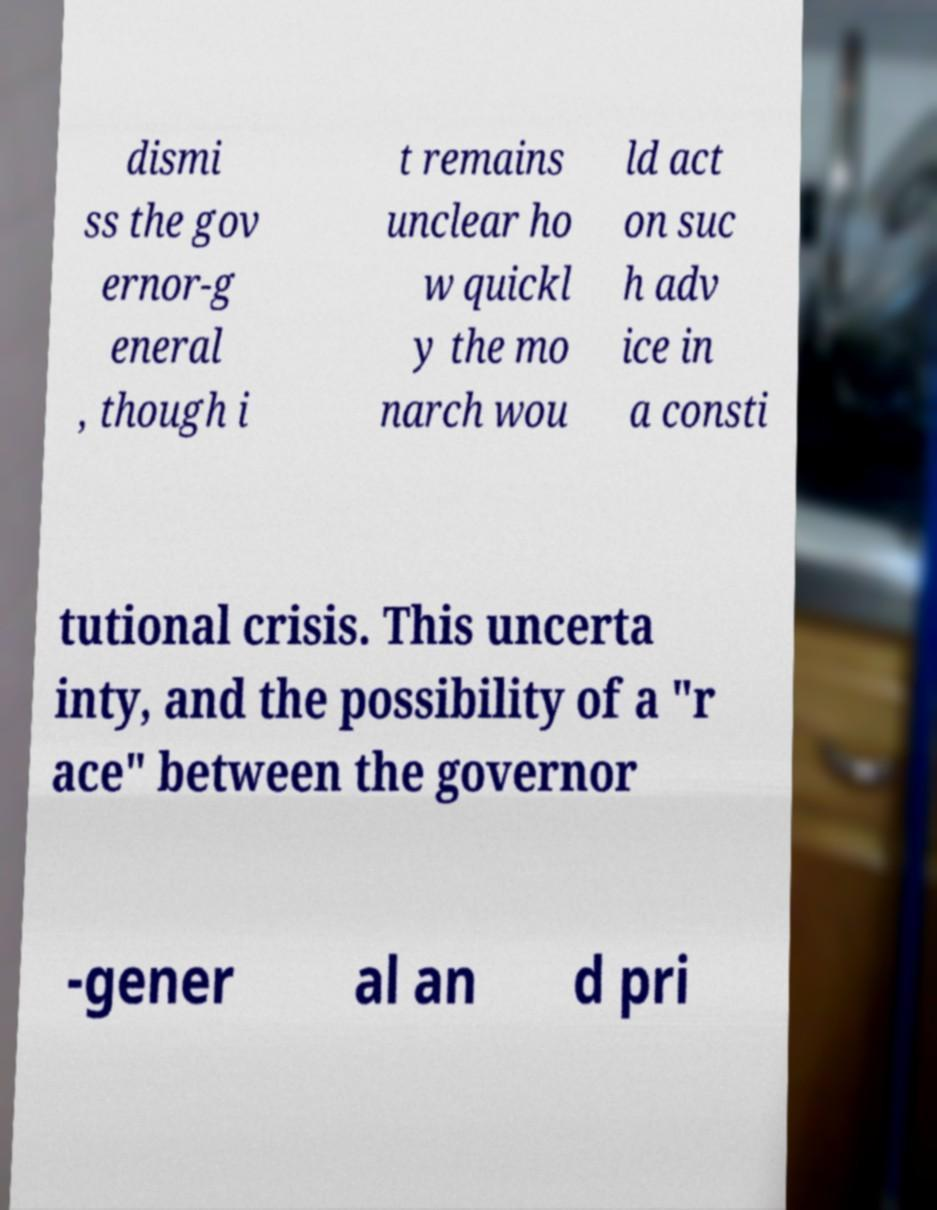Can you read and provide the text displayed in the image?This photo seems to have some interesting text. Can you extract and type it out for me? dismi ss the gov ernor-g eneral , though i t remains unclear ho w quickl y the mo narch wou ld act on suc h adv ice in a consti tutional crisis. This uncerta inty, and the possibility of a "r ace" between the governor -gener al an d pri 